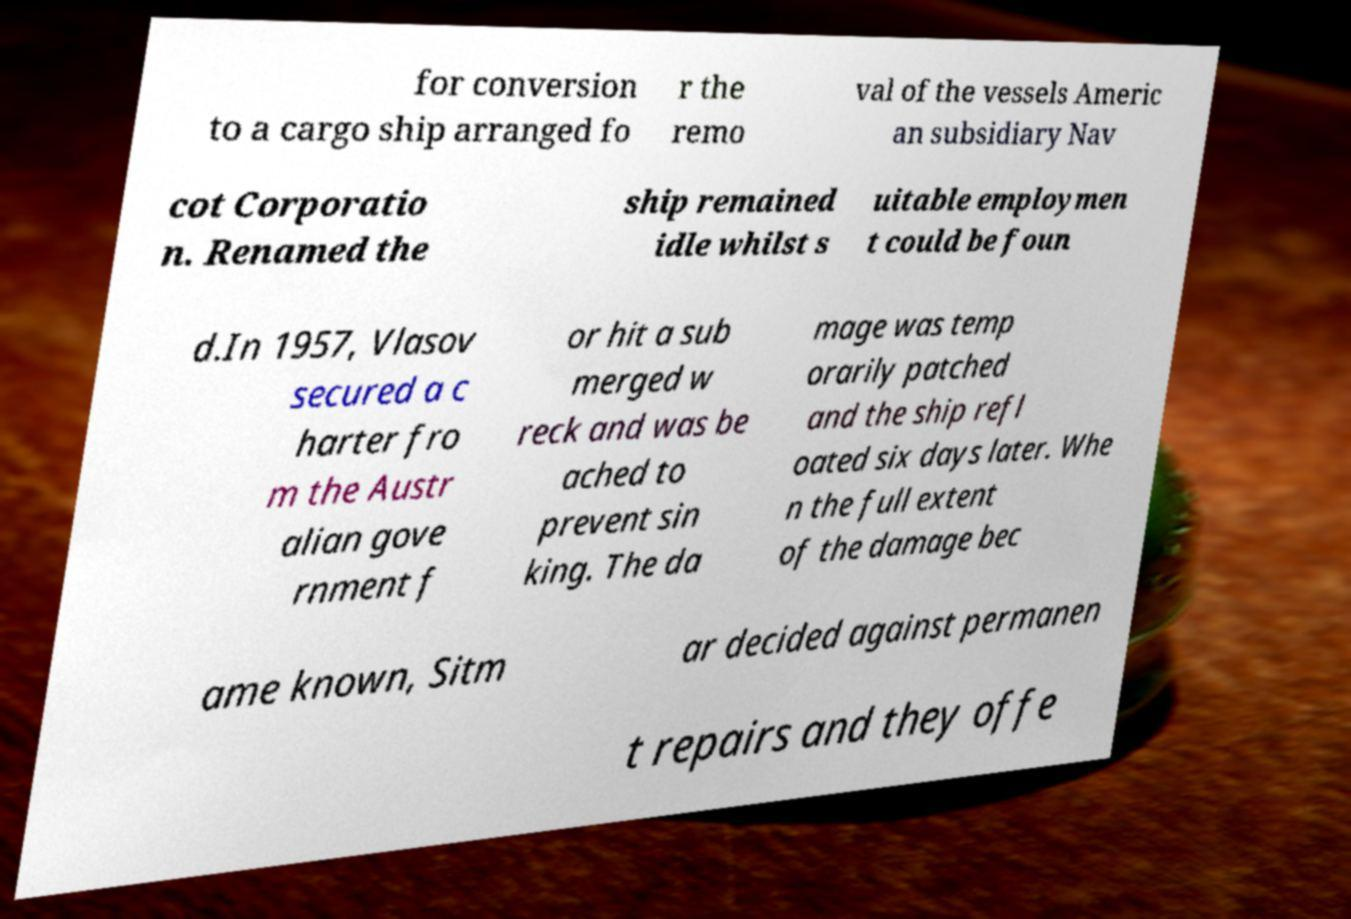What messages or text are displayed in this image? I need them in a readable, typed format. for conversion to a cargo ship arranged fo r the remo val of the vessels Americ an subsidiary Nav cot Corporatio n. Renamed the ship remained idle whilst s uitable employmen t could be foun d.In 1957, Vlasov secured a c harter fro m the Austr alian gove rnment f or hit a sub merged w reck and was be ached to prevent sin king. The da mage was temp orarily patched and the ship refl oated six days later. Whe n the full extent of the damage bec ame known, Sitm ar decided against permanen t repairs and they offe 